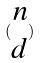Convert formula to latex. <formula><loc_0><loc_0><loc_500><loc_500>( \begin{matrix} n \\ d \end{matrix} )</formula> 